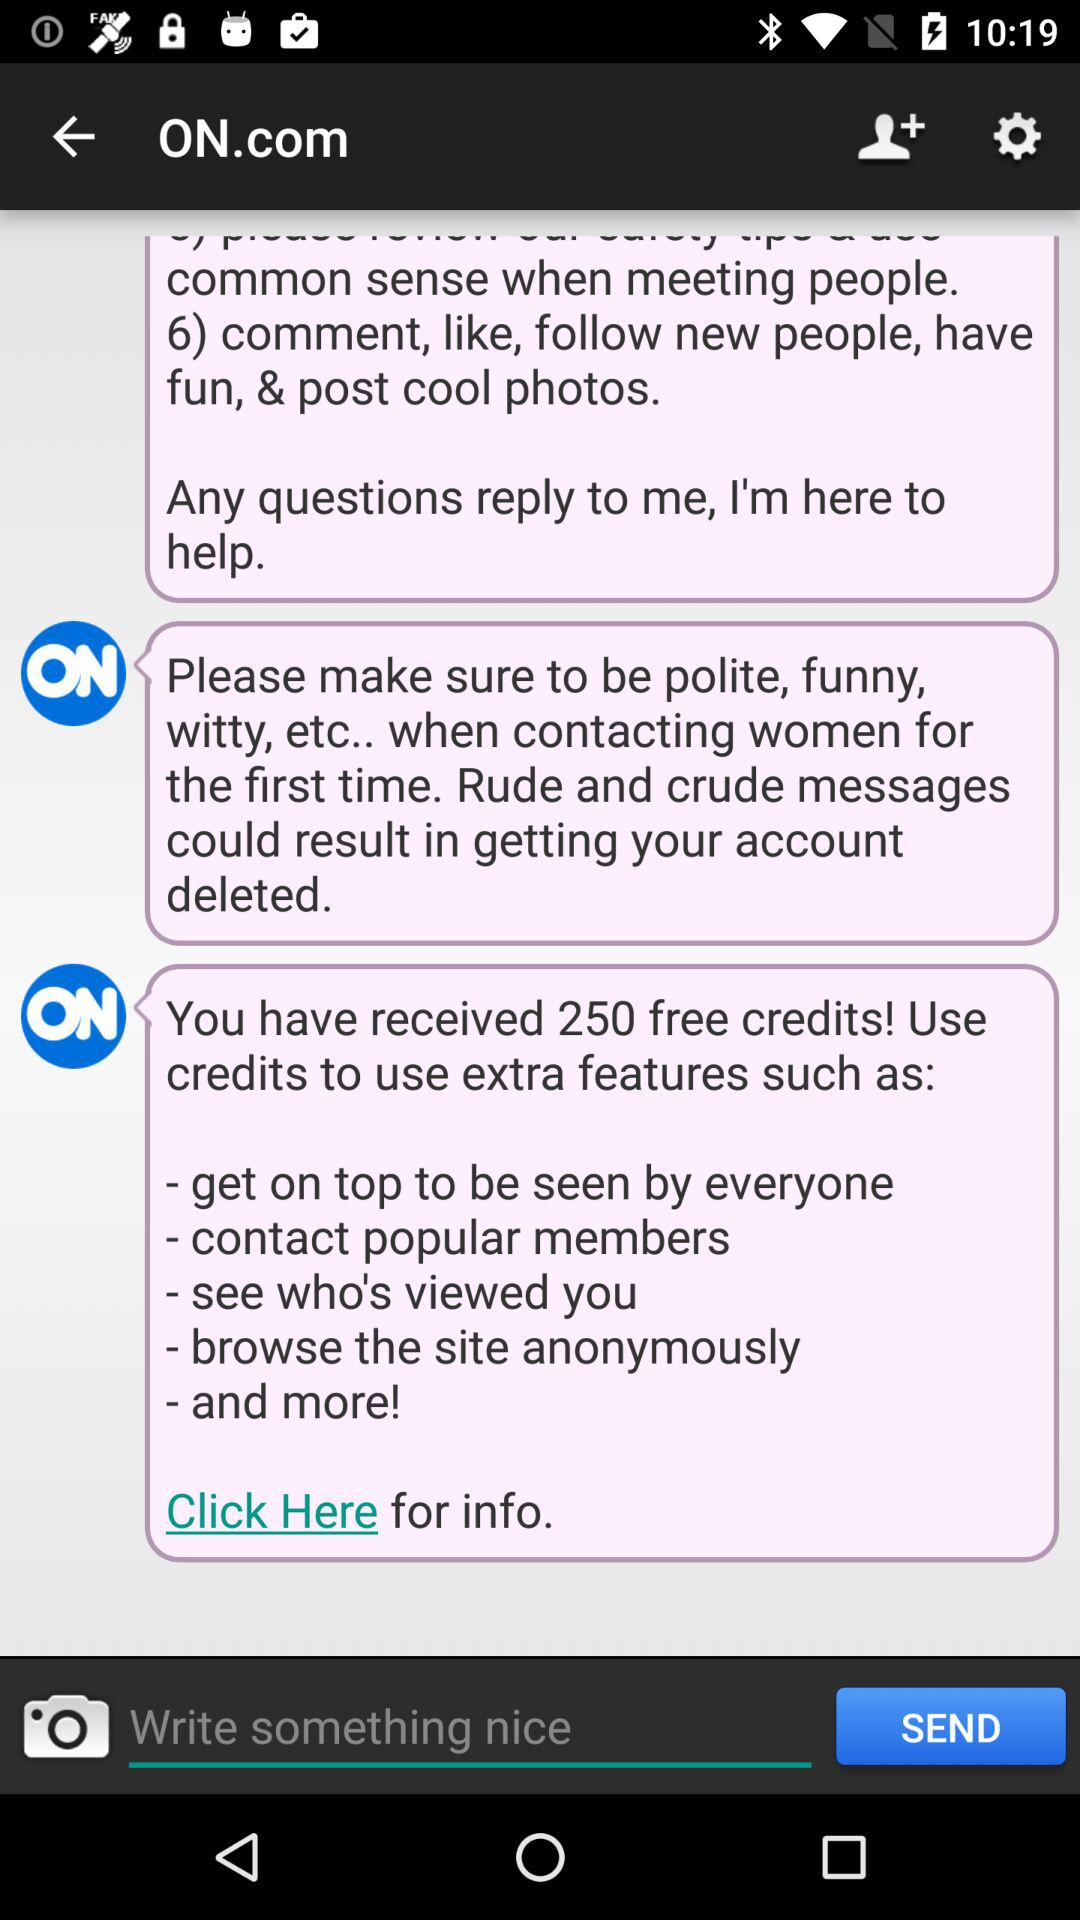How many credits does the user have?
Answer the question using a single word or phrase. 250 